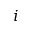<formula> <loc_0><loc_0><loc_500><loc_500>i</formula> 